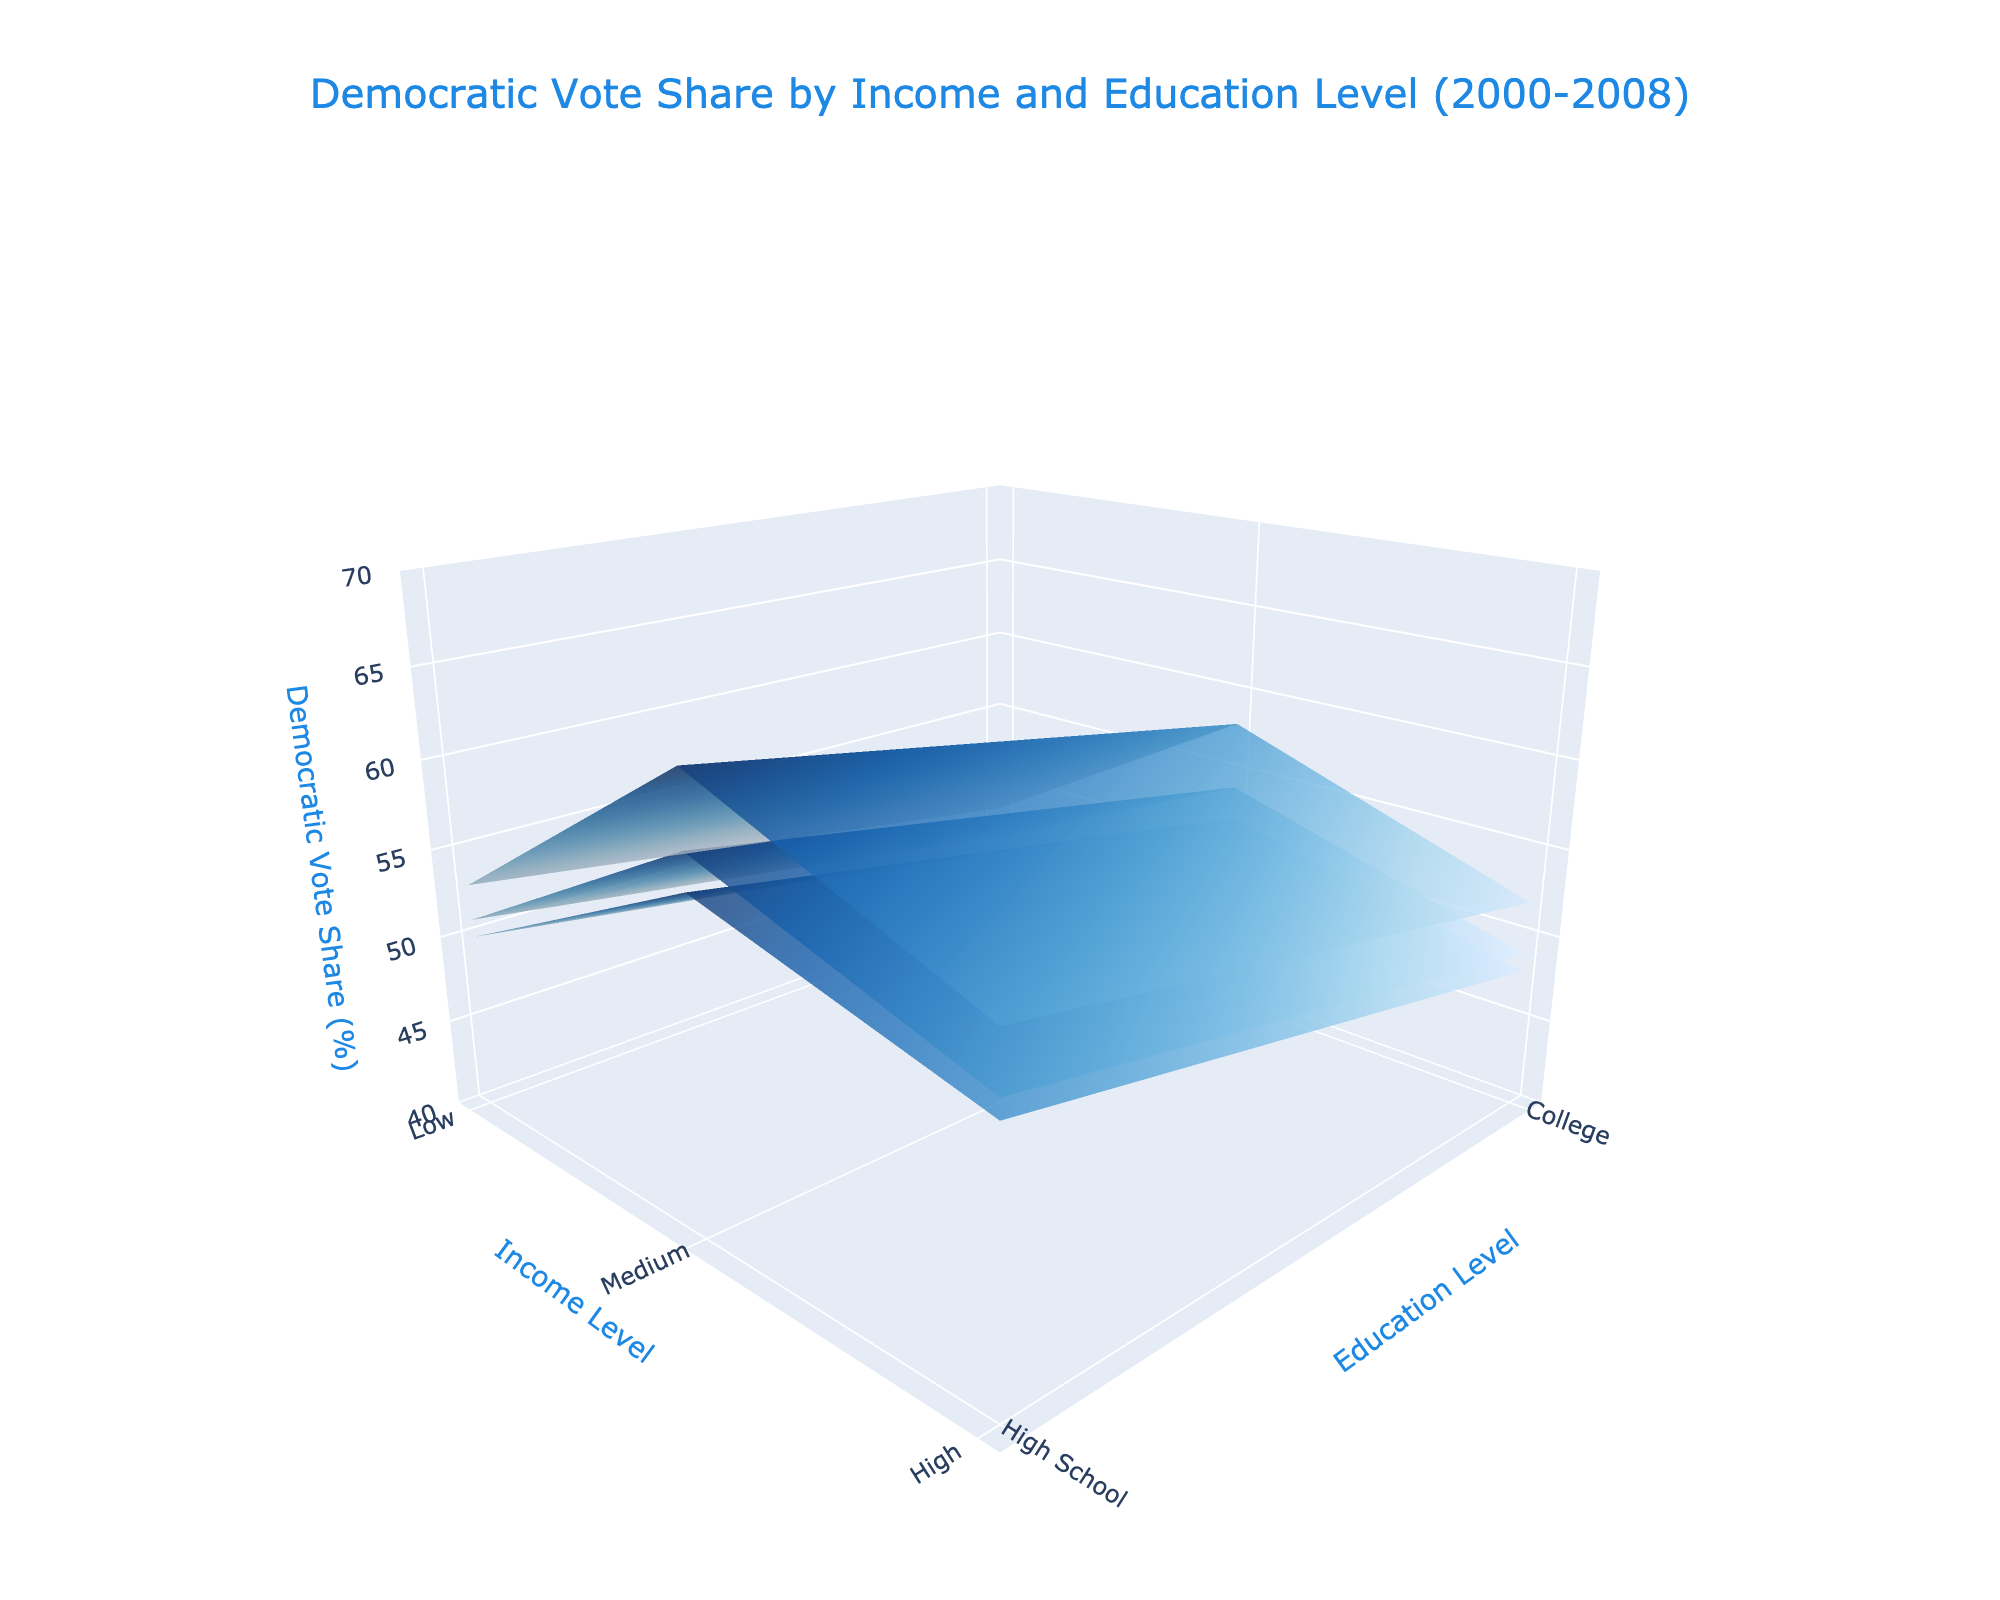What is the title of the plot? The title is displayed at the top of the plot in larger font size and it reads: "Democratic Vote Share by Income and Education Level (2000-2008)"
Answer: Democratic Vote Share by Income and Education Level (2000-2008) What are the axes labels for the plot? The x-axis represents Income Level, the y-axis represents Education Level, and the z-axis represents Democratic Vote Share (%). These labels are collectively mentioned in the scene's axis dictionary within the layout.
Answer: Income Level, Education Level, Democratic Vote Share (%) Which year shows the highest Democratic vote share for low-income individuals with a college education? By examining the plot, locate the surfaces corresponding to each year and find the highest z-value (Democratic Vote Share) for low-income individuals with a college education. In 2008, the z-value reaches 64%, the highest share.
Answer: 2008 How does the Democratic vote share for medium-income groups with a high school education change from 2000 to 2008? Compare the z-values (Democratic Vote Share) for medium-income groups with a high school education for the years 2000, 2004, and 2008 by checking the surfaces. The values are 48%, 49%, and 52% respectively, indicating an increasing trend.
Answer: Increasing from 48% to 52% Compare the Democratic vote share for high-income individuals with a high school education between 2000 and 2004. Check the z-values for high-income individuals with a high school education in 2000 and 2004. The values are 45% for 2000 and 46% for 2004, showing a slight increase.
Answer: Slight increase from 45% to 46% Which income level and education combination had the lowest Democratic vote share in 2008? Look for the minimum z-value (Democratic Vote Share) on the 2008 surface by inspecting all combinations of income levels and education. The lowest share is for high-income individuals with a high school education at 48%.
Answer: High income, High school education What trend can be observed in the Democratic vote share for low-income, high school educated individuals from 2000 to 2008? Check the z-values for low-income, high school educated individuals across the years 2000, 2004, and 2008. The values are 52%, 54%, and 58% respectively. This shows a consistent increasing trend in vote share.
Answer: Increasing trend from 52% to 58% What was the Democratic vote share for medium-income individuals with a college education in 2004? Locate the specific year and the intersection for medium-income and college education on the 3D surface. The z-value representing the Democratic vote share is 55%.
Answer: 55% Is the Democratic vote share generally higher for individuals with a college education compared to those with a high school education in the same income level? Compare the z-values for college and high school educated individuals within each income level for all years. Across all income levels and years, college educated individuals consistently have higher Democratic vote shares.
Answer: Yes 